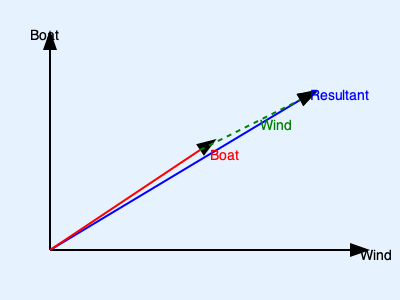As a competitive watersports school owner, you're analyzing wind patterns to optimize sailboat speed. In the vector diagram, the blue arrow represents the resultant velocity of a sailboat, the red arrow represents the boat's velocity relative to water, and the green dashed arrow represents the wind velocity. If the magnitude of the wind velocity is 15 knots and the boat's velocity relative to water is 12 knots, what is the angle between the wind direction and the boat's direction to achieve the maximum resultant velocity? To find the angle that maximizes the resultant velocity, we need to use the principles of vector addition and the concept of right triangles. Here's a step-by-step explanation:

1) The diagram shows a vector triangle where:
   - The red vector is the boat's velocity relative to water
   - The green dashed vector is the wind velocity
   - The blue vector is the resultant velocity

2) To maximize the resultant velocity (blue vector), we want to create a right triangle with the wind vector (green) and the boat's velocity vector (red).

3) In a right triangle, we can use the Pythagorean theorem: $a^2 + b^2 = c^2$

4) Let $\theta$ be the angle between the wind direction and the boat's direction. We want to find this angle.

5) Using trigonometry in the right triangle:
   $\cos(\theta) = \frac{\text{adjacent}}{\text{hypotenuse}} = \frac{\text{boat velocity}}{\text{wind velocity}}$

6) We know:
   - Boat velocity = 12 knots
   - Wind velocity = 15 knots

7) Plugging in the values:
   $\cos(\theta) = \frac{12}{15} = 0.8$

8) To find $\theta$, we take the inverse cosine (arccos):
   $\theta = \arccos(0.8)$

9) Calculating this:
   $\theta \approx 36.87°$

Therefore, the angle between the wind direction and the boat's direction that maximizes the resultant velocity is approximately 37°.
Answer: 37° 